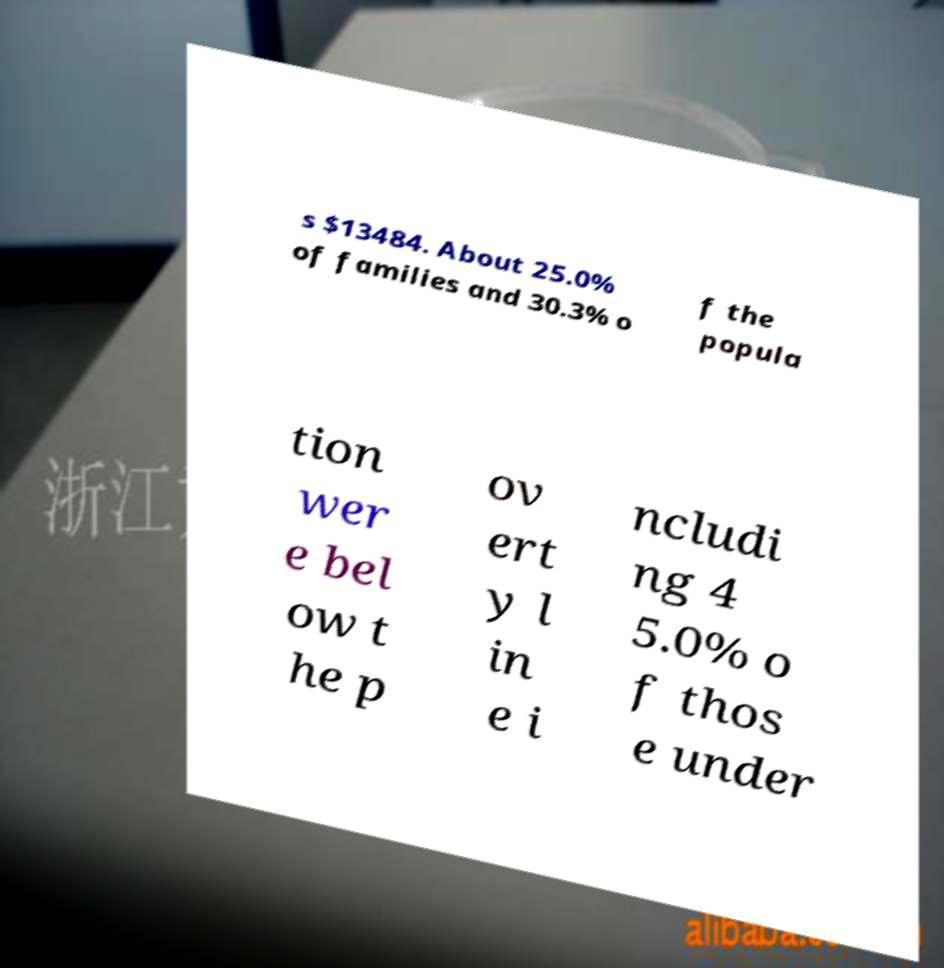Please identify and transcribe the text found in this image. s $13484. About 25.0% of families and 30.3% o f the popula tion wer e bel ow t he p ov ert y l in e i ncludi ng 4 5.0% o f thos e under 